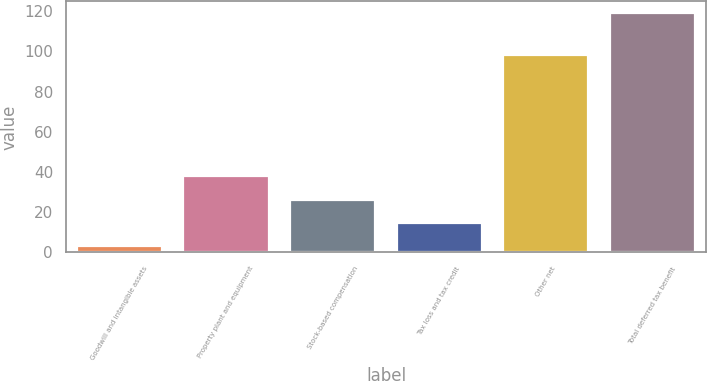Convert chart to OTSL. <chart><loc_0><loc_0><loc_500><loc_500><bar_chart><fcel>Goodwill and intangible assets<fcel>Property plant and equipment<fcel>Stock-based compensation<fcel>Tax loss and tax credit<fcel>Other net<fcel>Total deferred tax benefit<nl><fcel>3<fcel>37.8<fcel>26.2<fcel>14.6<fcel>98<fcel>119<nl></chart> 